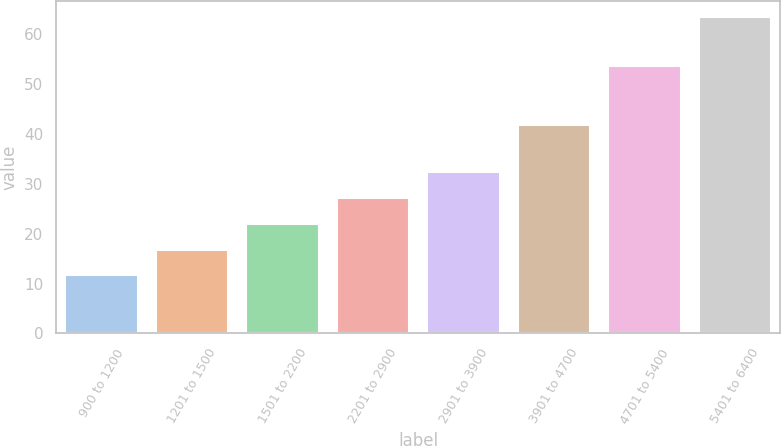Convert chart to OTSL. <chart><loc_0><loc_0><loc_500><loc_500><bar_chart><fcel>900 to 1200<fcel>1201 to 1500<fcel>1501 to 2200<fcel>2201 to 2900<fcel>2901 to 3900<fcel>3901 to 4700<fcel>4701 to 5400<fcel>5401 to 6400<nl><fcel>11.63<fcel>16.8<fcel>21.97<fcel>27.14<fcel>32.31<fcel>41.63<fcel>53.43<fcel>63.32<nl></chart> 